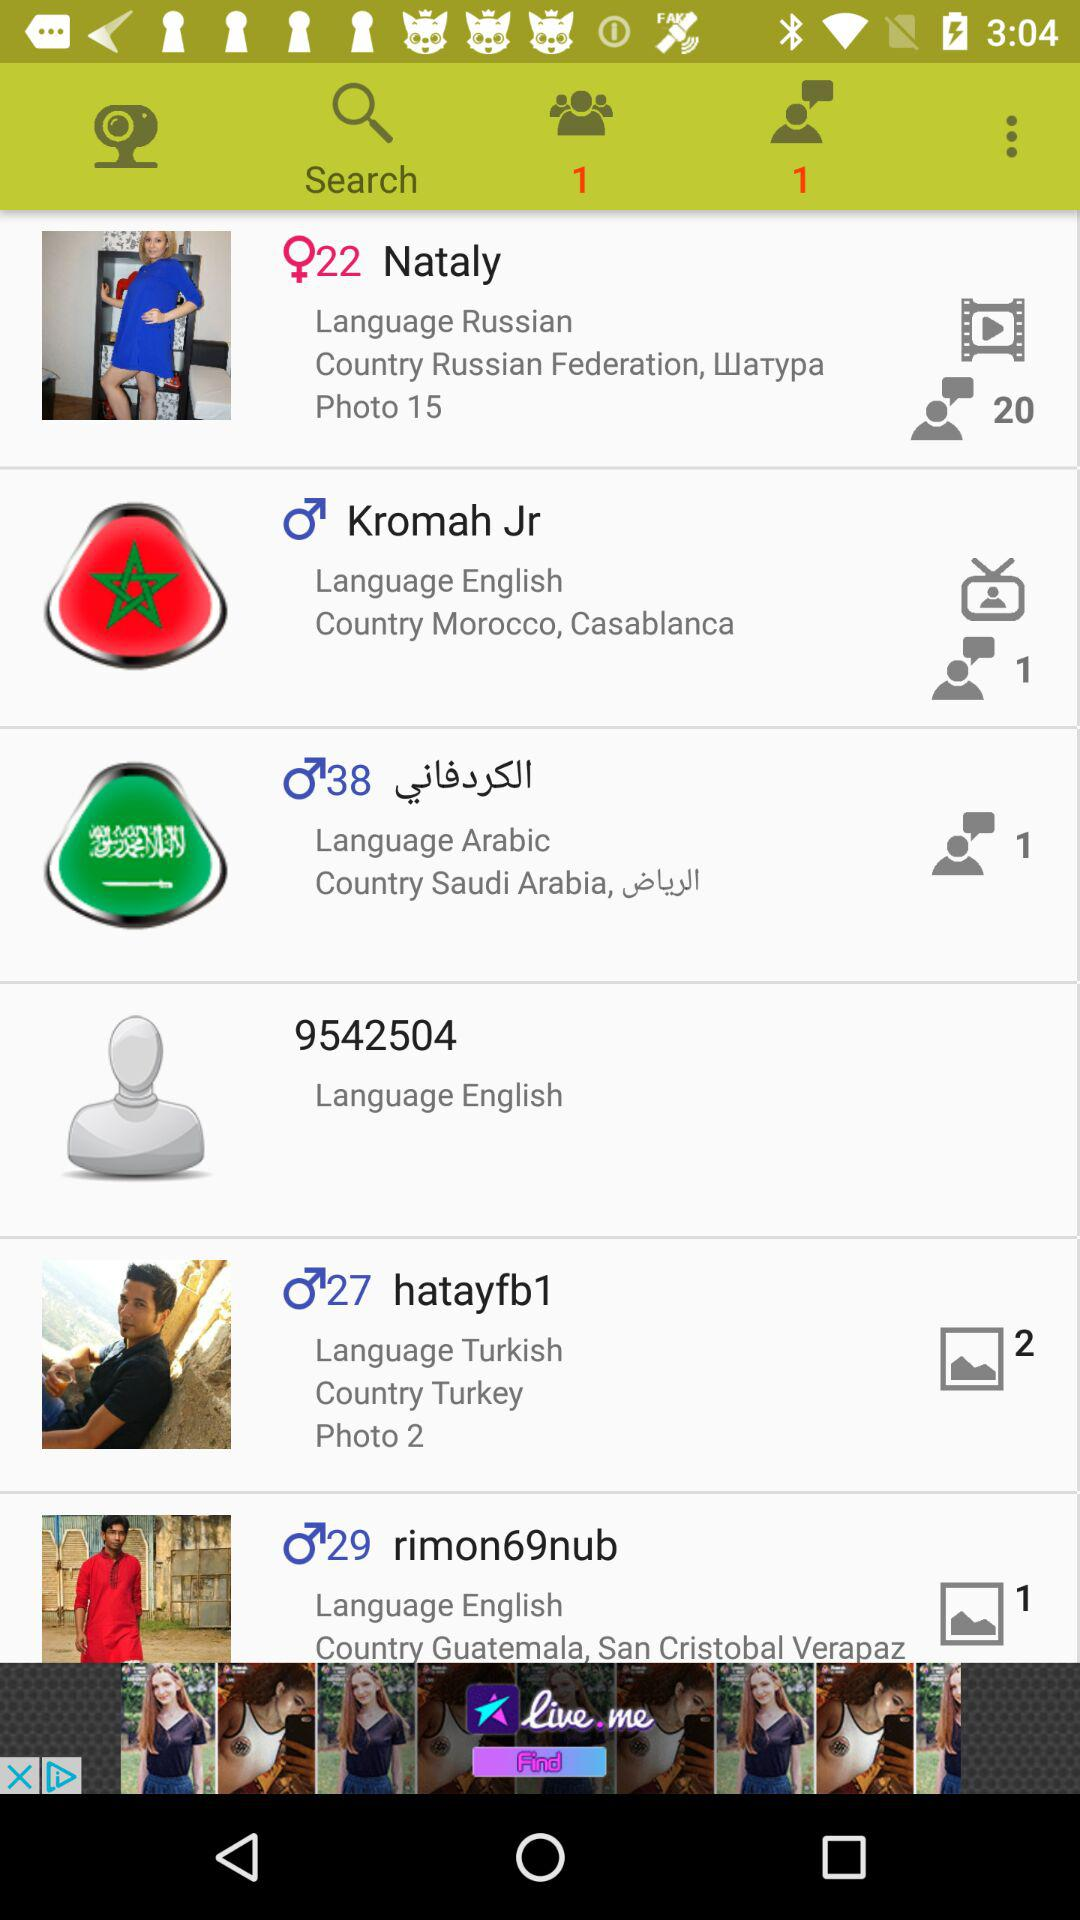What is the number of new friend requests? The number of new friend requests is 1. 